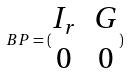Convert formula to latex. <formula><loc_0><loc_0><loc_500><loc_500>B P = ( \begin{matrix} I _ { r } & G \\ 0 & 0 \end{matrix} )</formula> 